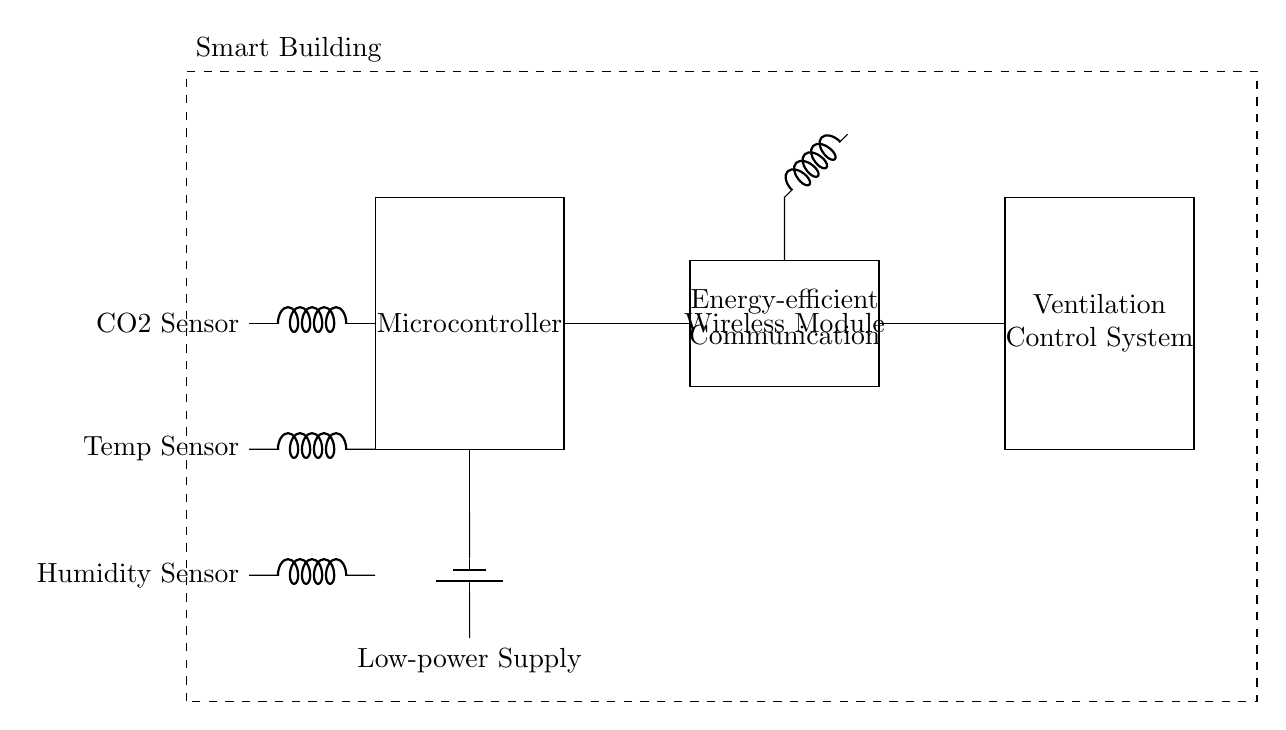What sensors are present in the circuit? The circuit diagram includes three sensors: a CO2 Sensor, a Temperature Sensor, and a Humidity Sensor. Each of these sensors is depicted on the left side of the diagram.
Answer: CO2 Sensor, Temperature Sensor, Humidity Sensor What is the function of the microcontroller? The microcontroller is designed to control the operation of the system based on the data received from the sensors. It processes the input signals and manages the ventilation control system.
Answer: Control operation What supplies power to the microcontroller? The microcontroller is powered by a Low-power Supply, which is represented by the battery symbol in the circuit diagram connected directly to it.
Answer: Low-power Supply How does the wireless module connect to the microcontroller? The Wireless Module connects to the Microcontroller through a direct wire connection (represented by the line drawn from the microcontroller to the wireless module) which facilitates communication between them.
Answer: Direct connection What component receives data from the sensors? The microcontroller receives data from all three sensors (CO2, Temperature, Humidity) and processes that data before sending commands to the ventilation control system.
Answer: Microcontroller What is the purpose of the ventilation control system? The Ventilation Control System is responsible for adjusting the building's ventilation based on the data processed by the microcontroller to maintain indoor air quality.
Answer: Adjust ventilation 